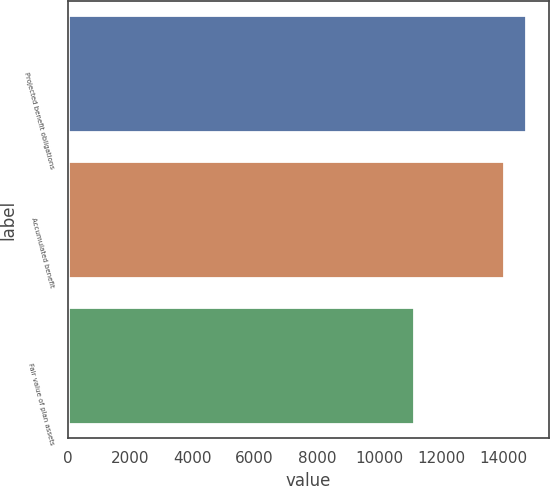Convert chart to OTSL. <chart><loc_0><loc_0><loc_500><loc_500><bar_chart><fcel>Projected benefit obligations<fcel>Accumulated benefit<fcel>Fair value of plan assets<nl><fcel>14713<fcel>14012<fcel>11125<nl></chart> 